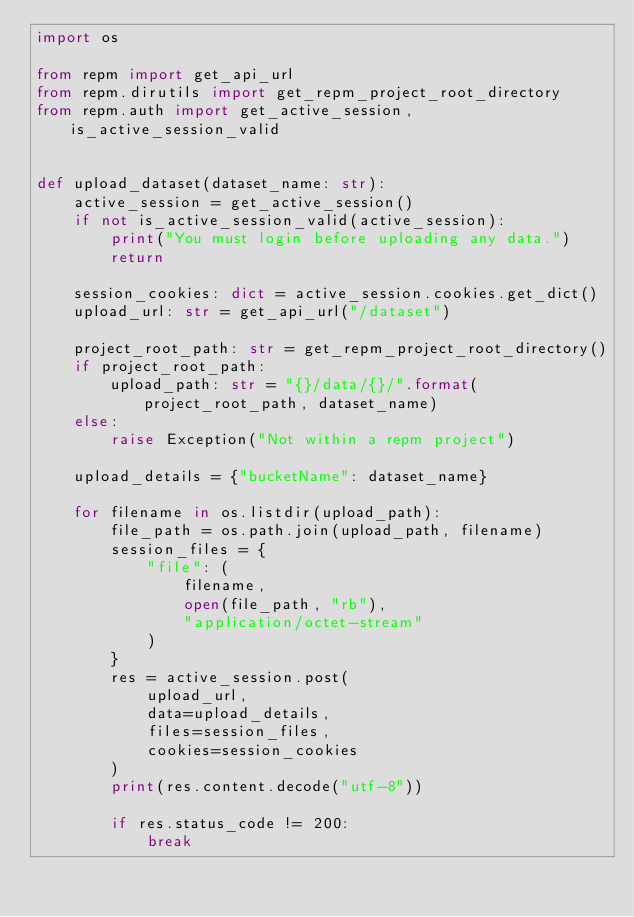<code> <loc_0><loc_0><loc_500><loc_500><_Python_>import os

from repm import get_api_url
from repm.dirutils import get_repm_project_root_directory
from repm.auth import get_active_session, is_active_session_valid


def upload_dataset(dataset_name: str):
    active_session = get_active_session()
    if not is_active_session_valid(active_session):
        print("You must login before uploading any data.")
        return

    session_cookies: dict = active_session.cookies.get_dict()
    upload_url: str = get_api_url("/dataset")

    project_root_path: str = get_repm_project_root_directory()
    if project_root_path:
        upload_path: str = "{}/data/{}/".format(project_root_path, dataset_name)
    else:
        raise Exception("Not within a repm project")

    upload_details = {"bucketName": dataset_name}

    for filename in os.listdir(upload_path):
        file_path = os.path.join(upload_path, filename)
        session_files = {
            "file": (
                filename,
                open(file_path, "rb"),
                "application/octet-stream"
            )
        }
        res = active_session.post(
            upload_url,
            data=upload_details,
            files=session_files,
            cookies=session_cookies
        )
        print(res.content.decode("utf-8"))

        if res.status_code != 200:
            break
</code> 